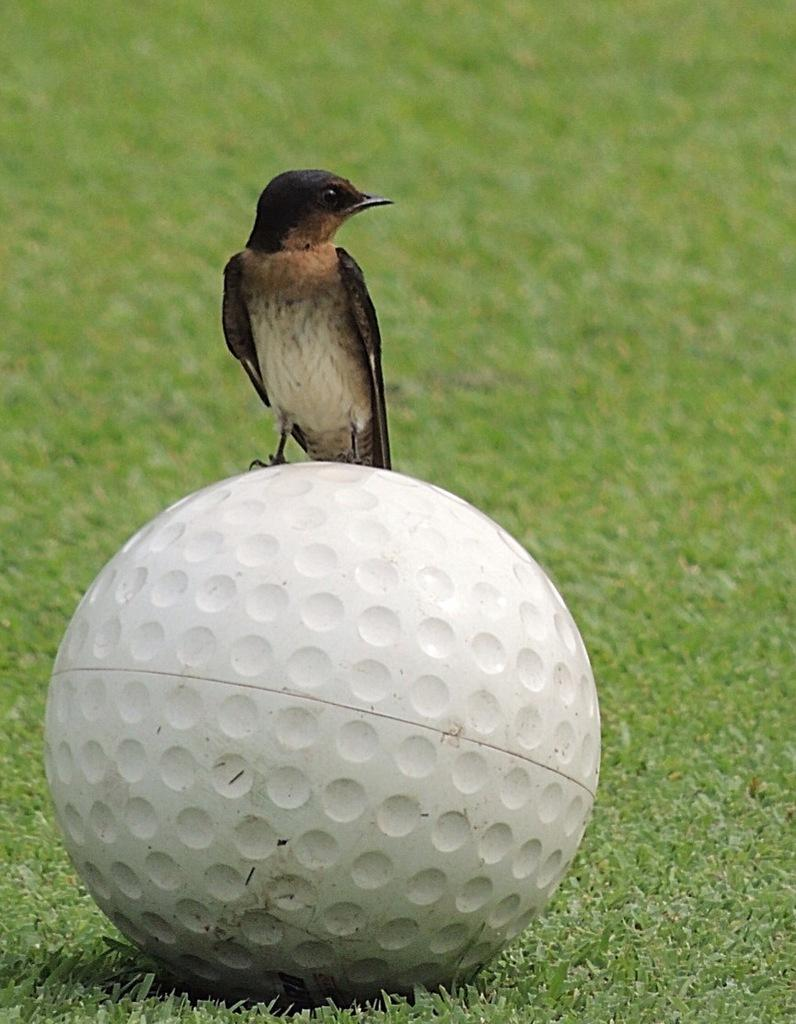What type of animal is in the image? There is a bird in the image. What is the bird standing on? The bird is on a ball. Where is the ball located? The ball is on the grass. What type of income does the bird earn from being on the ball? There is no information about the bird's income in the image, as it is not relevant to the image's content. 